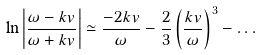Convert formula to latex. <formula><loc_0><loc_0><loc_500><loc_500>\ln \left | \frac { \omega - k v } { \omega + k v } \right | \simeq \frac { - 2 k v } { \omega } - \frac { 2 } { 3 } \left ( \frac { k v } { \omega } \right ) ^ { 3 } - \dots</formula> 